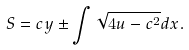<formula> <loc_0><loc_0><loc_500><loc_500>S = c y \pm \int \sqrt { 4 u - c ^ { 2 } } d x .</formula> 